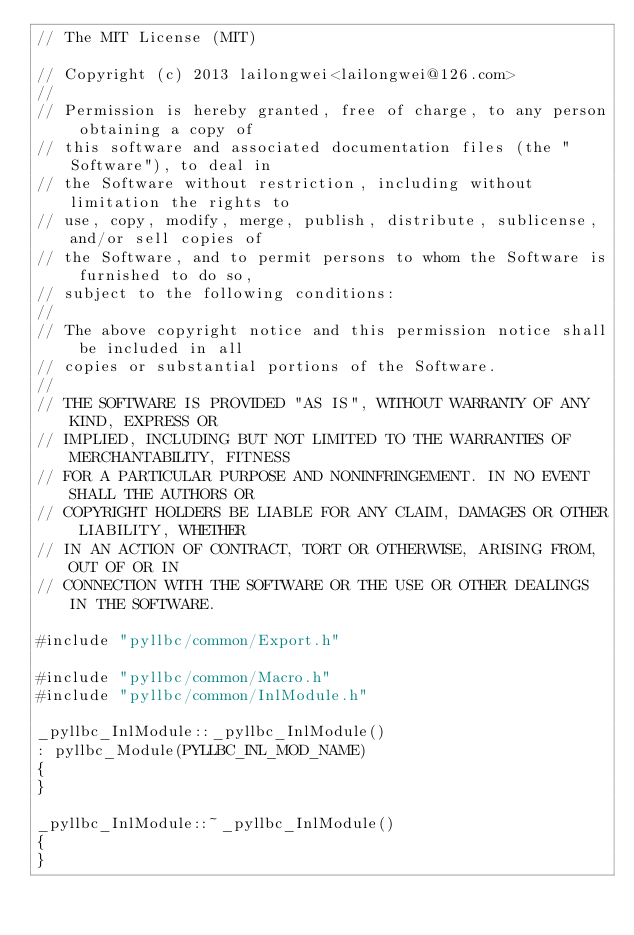Convert code to text. <code><loc_0><loc_0><loc_500><loc_500><_C++_>// The MIT License (MIT)

// Copyright (c) 2013 lailongwei<lailongwei@126.com>
// 
// Permission is hereby granted, free of charge, to any person obtaining a copy of 
// this software and associated documentation files (the "Software"), to deal in 
// the Software without restriction, including without limitation the rights to 
// use, copy, modify, merge, publish, distribute, sublicense, and/or sell copies of 
// the Software, and to permit persons to whom the Software is furnished to do so, 
// subject to the following conditions:
// 
// The above copyright notice and this permission notice shall be included in all 
// copies or substantial portions of the Software.
// 
// THE SOFTWARE IS PROVIDED "AS IS", WITHOUT WARRANTY OF ANY KIND, EXPRESS OR 
// IMPLIED, INCLUDING BUT NOT LIMITED TO THE WARRANTIES OF MERCHANTABILITY, FITNESS 
// FOR A PARTICULAR PURPOSE AND NONINFRINGEMENT. IN NO EVENT SHALL THE AUTHORS OR 
// COPYRIGHT HOLDERS BE LIABLE FOR ANY CLAIM, DAMAGES OR OTHER LIABILITY, WHETHER 
// IN AN ACTION OF CONTRACT, TORT OR OTHERWISE, ARISING FROM, OUT OF OR IN 
// CONNECTION WITH THE SOFTWARE OR THE USE OR OTHER DEALINGS IN THE SOFTWARE.

#include "pyllbc/common/Export.h"

#include "pyllbc/common/Macro.h"
#include "pyllbc/common/InlModule.h"

_pyllbc_InlModule::_pyllbc_InlModule()
: pyllbc_Module(PYLLBC_INL_MOD_NAME)
{
}

_pyllbc_InlModule::~_pyllbc_InlModule()
{
}
</code> 